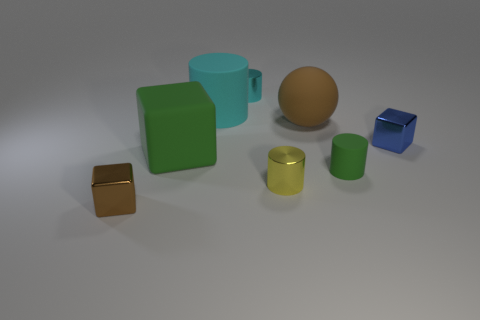There is a tiny metal cube to the left of the matte cylinder in front of the large brown object; what color is it? The tiny cube to the left of the matte cylinder is gold in color, exhibiting a shiny metallic finish that contrasts with the matte surface of the cylinder. 